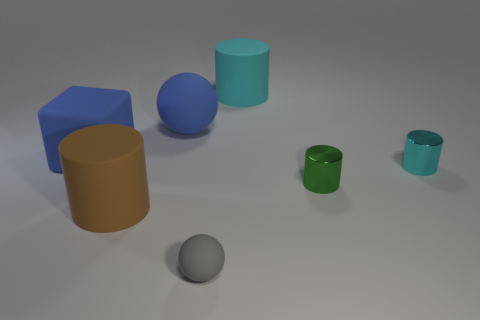Is the color of the matte cube the same as the large rubber ball?
Provide a succinct answer. Yes. There is a cube; is its color the same as the rubber sphere that is behind the block?
Provide a short and direct response. Yes. What material is the ball that is the same color as the large rubber cube?
Offer a terse response. Rubber. Is there a small cylinder that has the same color as the tiny rubber sphere?
Offer a very short reply. No. What number of metallic things are large purple blocks or small cyan things?
Your response must be concise. 1. Is there a tiny yellow ball made of the same material as the large blue ball?
Your answer should be very brief. No. How many rubber balls are both in front of the tiny green metallic object and behind the tiny green object?
Make the answer very short. 0. Are there fewer tiny gray objects that are to the right of the big blue block than matte objects that are behind the small cyan cylinder?
Your answer should be compact. Yes. Do the green shiny object and the small cyan thing have the same shape?
Offer a terse response. Yes. What number of other objects are the same size as the green metallic thing?
Provide a short and direct response. 2. 